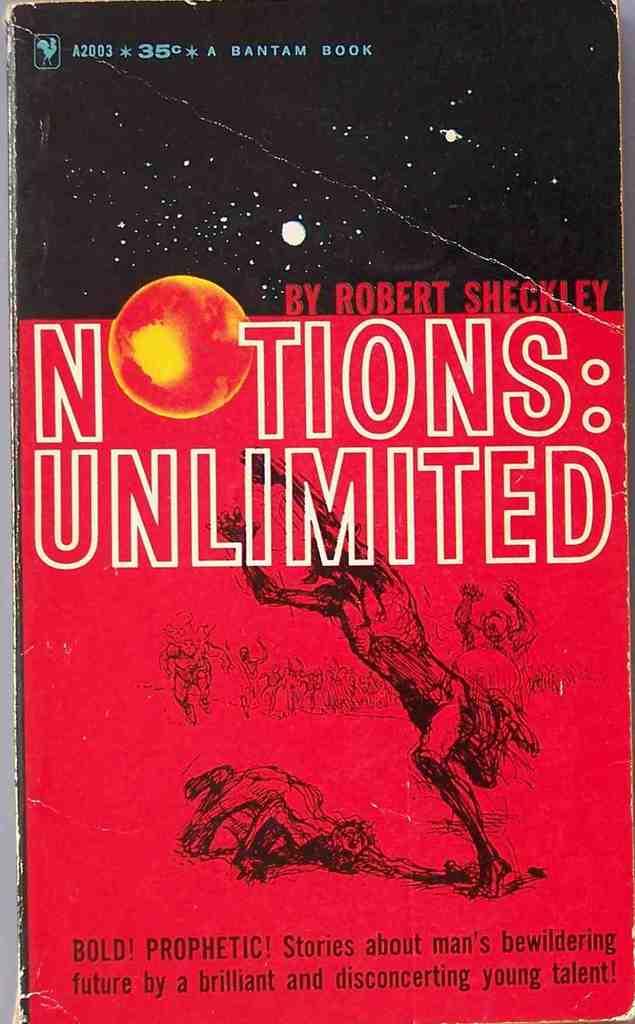Who is the book publisher?
Your answer should be very brief. Bantam. 